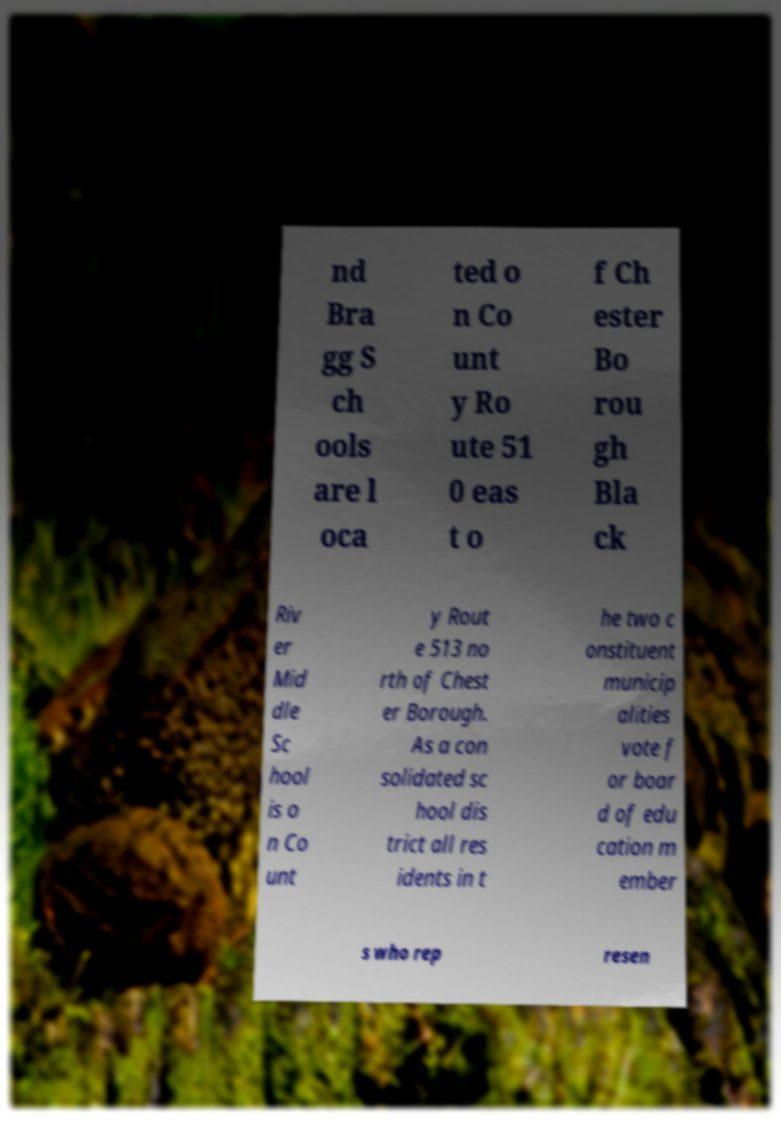What messages or text are displayed in this image? I need them in a readable, typed format. nd Bra gg S ch ools are l oca ted o n Co unt y Ro ute 51 0 eas t o f Ch ester Bo rou gh Bla ck Riv er Mid dle Sc hool is o n Co unt y Rout e 513 no rth of Chest er Borough. As a con solidated sc hool dis trict all res idents in t he two c onstituent municip alities vote f or boar d of edu cation m ember s who rep resen 